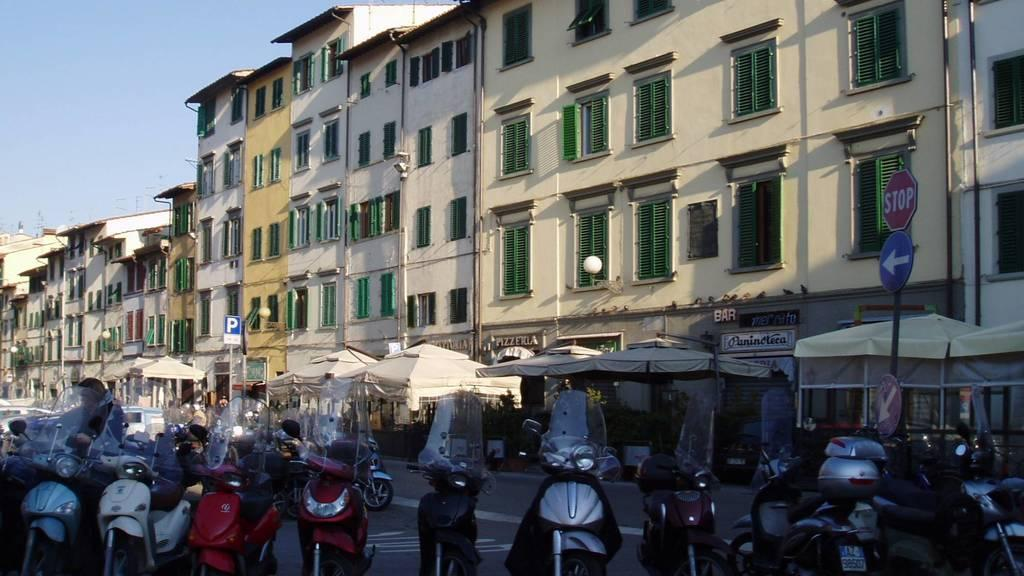What can be seen on the road in the image? There are vehicles on the road in the image. What else is visible in the image besides the vehicles? There are buildings visible in the image. What is visible at the top of the image? The sky is visible at the top of the image. Can you tell me how many goldfish are swimming in the sky in the image? There are no goldfish present in the image; it features vehicles on the road and buildings. What type of fruit is being sorted in the image? There is no fruit or sorting activity present in the image. 